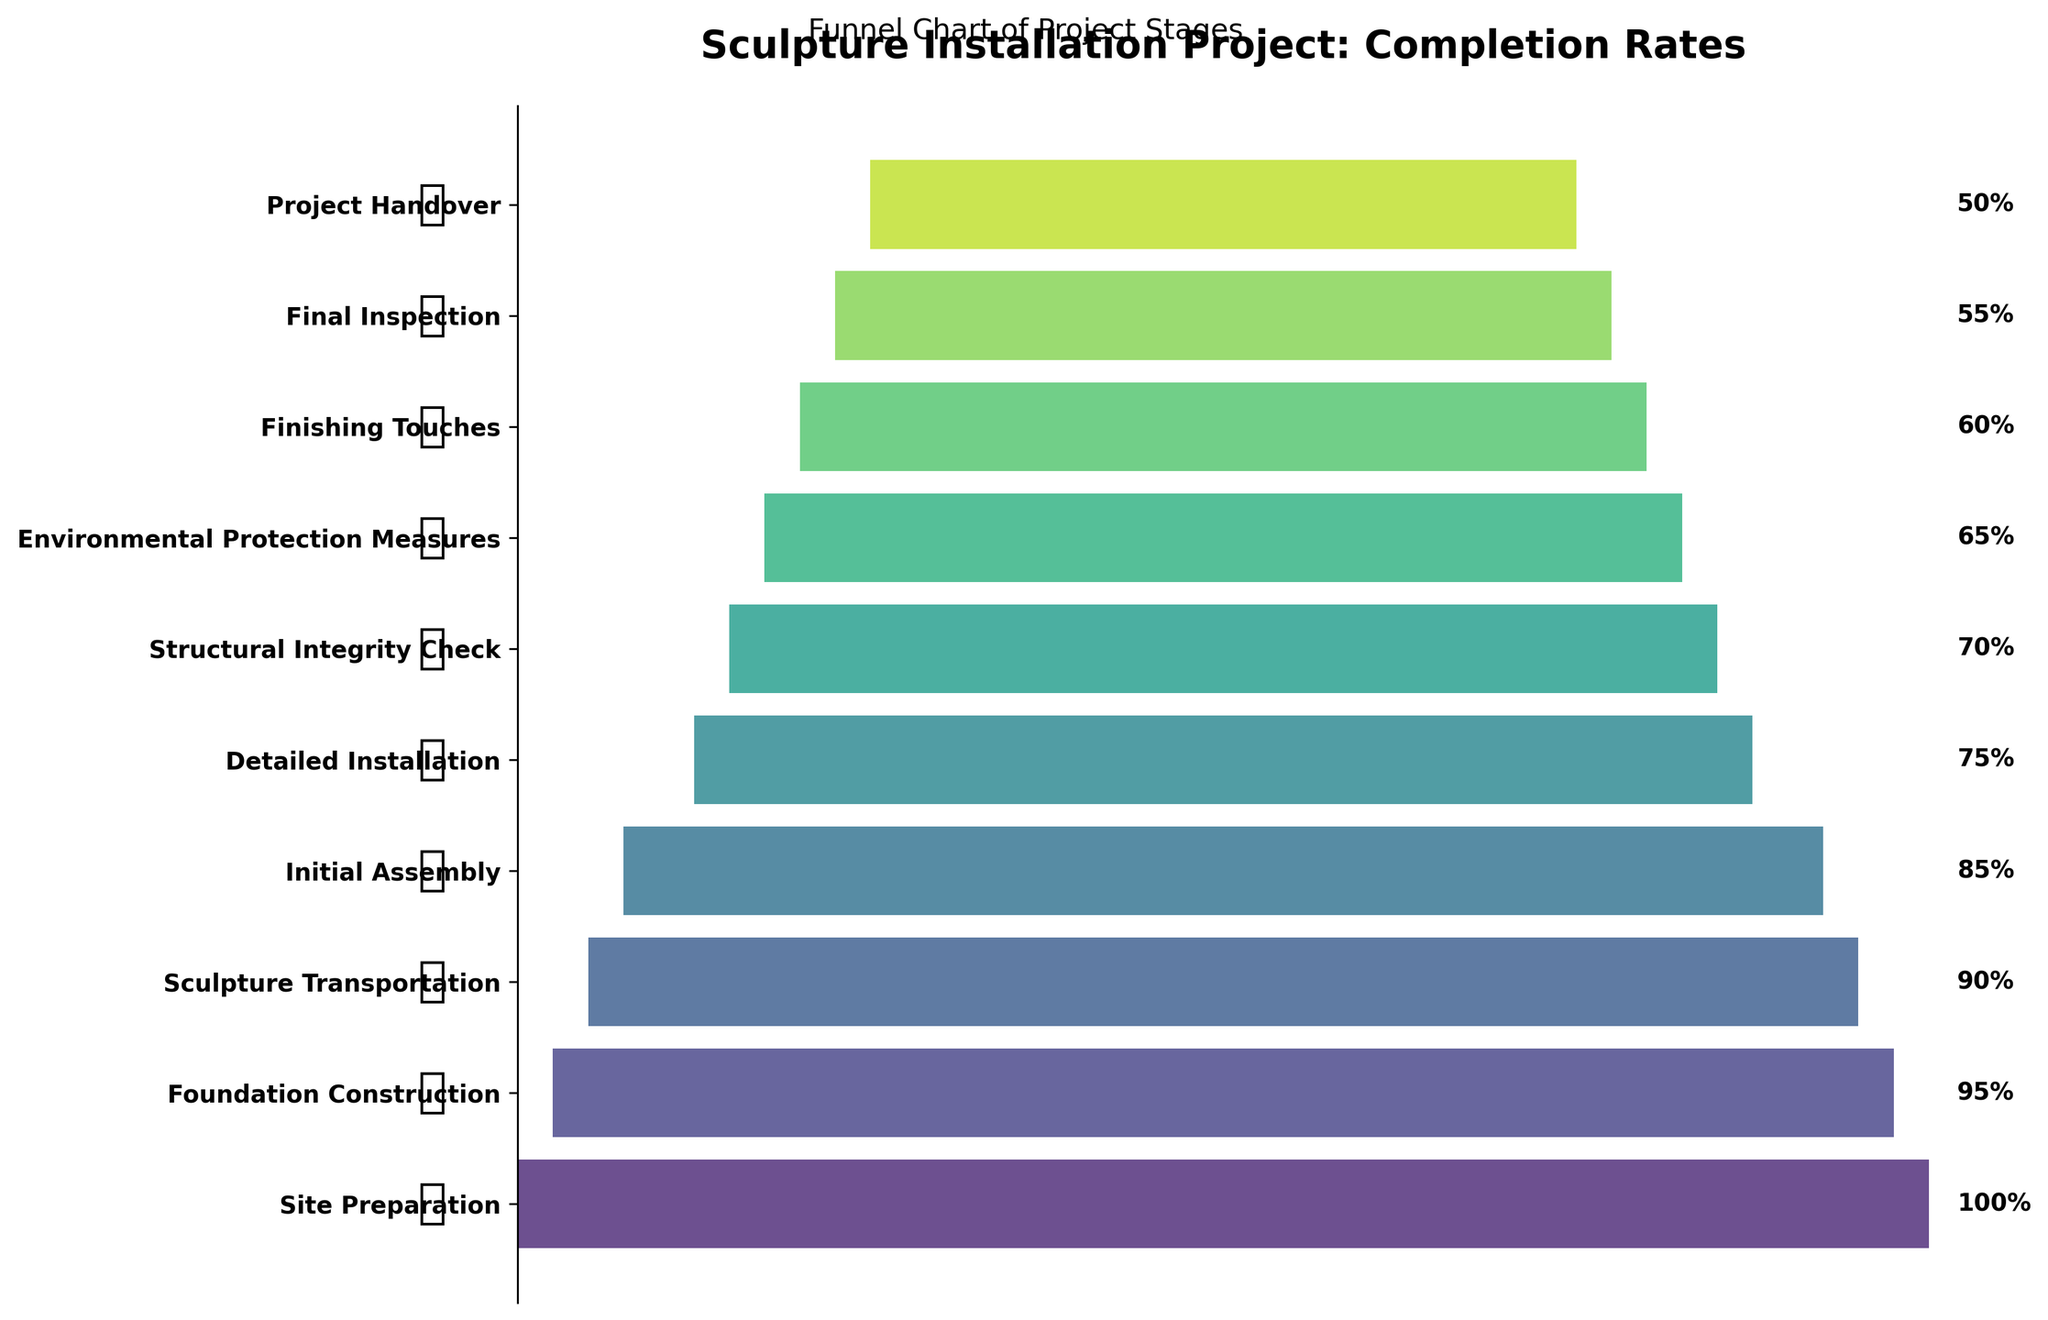what is the title of the figure? The title is typically found at the top of the chart. Here it is stated as "Sculpture Installation Project: Completion Rates".
Answer: Sculpture Installation Project: Completion Rates Which stage has the highest completion rate? The stage with the highest completion rate will be at the top of the funnel chart with the widest bar. In this figure, it is the "Site Preparation" stage with a 100% completion rate.
Answer: Site Preparation How many stages are represented in the funnel chart? Count the number of unique stages listed on the vertical axis of the funnel chart. There are 10 stages listed.
Answer: 10 Which stage has a 75% completion rate? Find the bar in the funnel chart where the completion rate label reads 75%. It's the "Detailed Installation" stage.
Answer: Detailed Installation What is the difference in completion rate between the Initial Assembly and Final Inspection stages? Identify the completion rates for both stages: Initial Assembly is 85%, and Final Inspection is 55%. Subtract the latter from the former: 85% - 55% = 30%.
Answer: 30% What is the average completion rate of the Environmental Protection Measures and Finishing Touches stages? Identify the completion rates for both stages: Environmental Protection Measures is 65%, and Finishing Touches is 60%. Calculate the average: (65% + 60%) / 2 = 62.5%.
Answer: 62.5% Which stage shows a completion rate that is halfway between the highest and lowest completion rates? The highest completion rate is 100% (Site Preparation) and the lowest is 50% (Project Handover). Halfway would be (100% + 50%) / 2 = 75%. The "Detailed Installation" stage has a 75% completion rate.
Answer: Detailed Installation How does the completion rate for Structural Integrity Check compare to that for Initial Assembly? For Structural Integrity Check, the completion rate is 70%, whereas for Initial Assembly, it is 85%. Thus, the completion rate for Initial Assembly is higher by 15%.
Answer: Initial Assembly is 15% higher What percentage less is the Project Handover stage's completion rate compared to the Initial Assembly stage? The completion rate for Project Handover is 50%, and for Initial Assembly, it is 85%. Difference is 85% - 50% = 35%. Thus, Project Handover is 35% less.
Answer: 35% less Which stages have a completion rate less than 70%? Identify bars with a completion rate less than 70%. These stages are Environmental Protection Measures (65%), Finishing Touches (60%), Final Inspection (55%), and Project Handover (50%).
Answer: Environmental Protection Measures, Finishing Touches, Final Inspection, Project Handover 